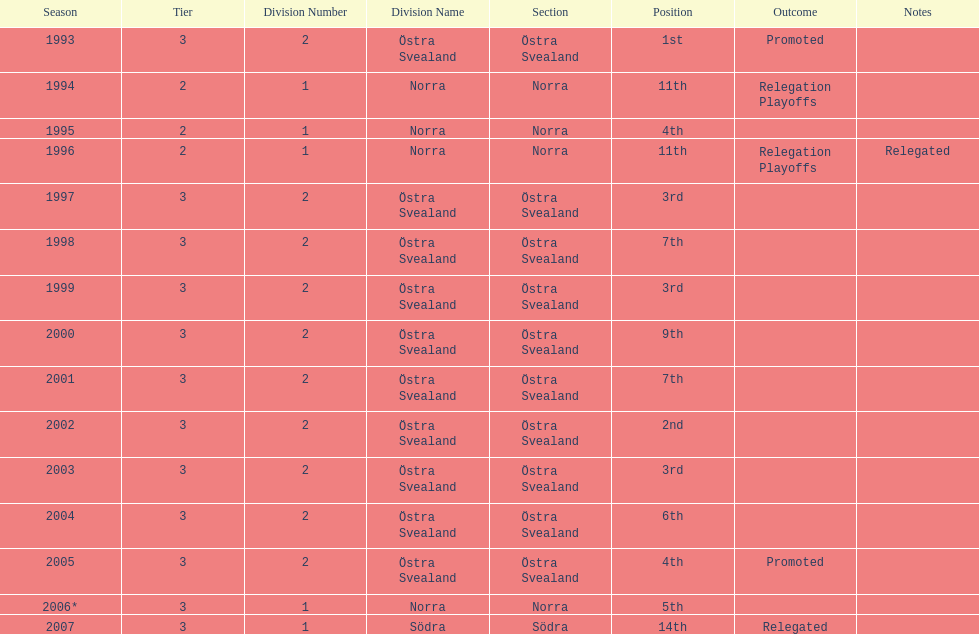Which year was more successful, 2007 or 2002? 2002. 